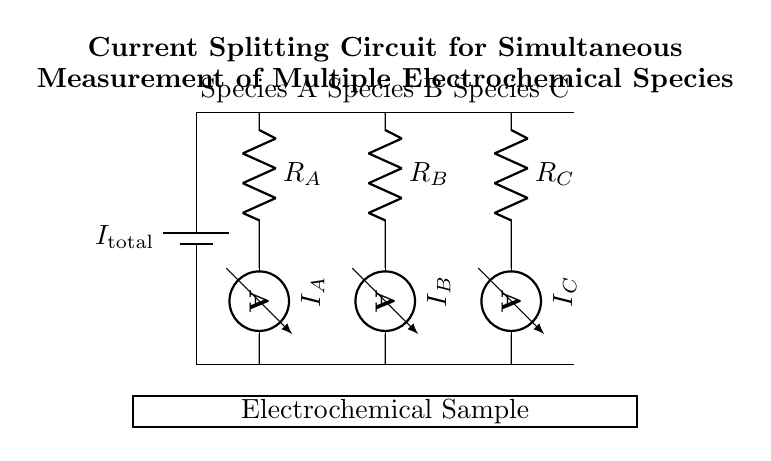What is the total current supplied by the battery? The diagram indicates the total current pushed into the circuit by the battery, labeled as "I_total." There are no numbers, but this represents the current feeding the branches leading to each electrochemical measurement.
Answer: I_total How many branches are there for current division? Observing the circuit diagram, we see three distinct branches labeled R_A, R_B, and R_C, each leading to an ammeter that measures the respective currents. This shows that each branch is designed for a separate electrochemical species.
Answer: 3 What are the resistances associated with the branches? The resistors in each branch are labeled as R_A, R_B, and R_C. Each of these resistors plays a critical role in determining how the total current is split among the branches; however, the exact numerical values are not provided in the circuit.
Answer: R_A, R_B, R_C Which species has the ammeter reading I_B? The ammeter indicating I_B is connected to the resistor labeled R_B, which signifies that it measures the current flowing through the branch designated for species B. Hence, it corresponds to the second branch in the current divider circuit layout.
Answer: Species B How does the total current divide among the branches? The current division in this circuit follows Ohm's law and the principle of parallel circuits, where the current flowing through each branch is inversely proportional to its resistance. Therefore, larger resistances will have less current flowing through them, while smaller resistances will have more. This means the splitting depends on the resistance values of R_A, R_B, and R_C.
Answer: According to resistance values What role does the sample container play in the circuit? The sample container is represented as a rectangle in the diagram, which indicates that it is the site where the electrochemical reactions occur. The applied currents from each branch flow through the sample, allowing for the simultaneous measurement of the different species present.
Answer: Electrochemical reactions What can you infer about the relationship between I_A, I_B, and I_C? The total current I_total is equal to the sum of the currents in the branches, articulated as I_total = I_A + I_B + I_C. This equation illustrates how the total incoming current is split among the branches. Each branch's current reading reflects the concentration of the electrochemical species being measured.
Answer: I_total = I_A + I_B + I_C 